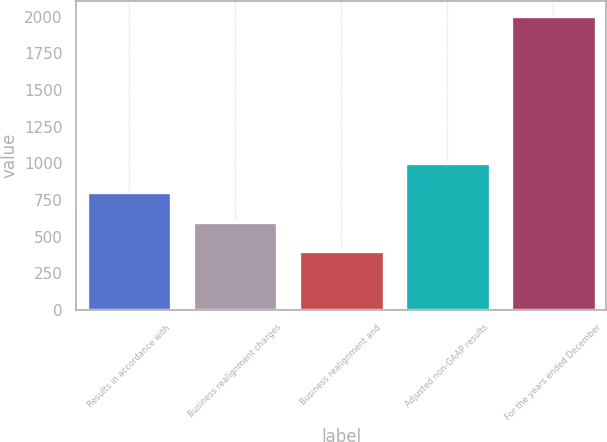Convert chart to OTSL. <chart><loc_0><loc_0><loc_500><loc_500><bar_chart><fcel>Results in accordance with<fcel>Business realignment charges<fcel>Business realignment and<fcel>Adjusted non-GAAP results<fcel>For the years ended December<nl><fcel>802.02<fcel>601.52<fcel>401.02<fcel>1002.52<fcel>2005<nl></chart> 